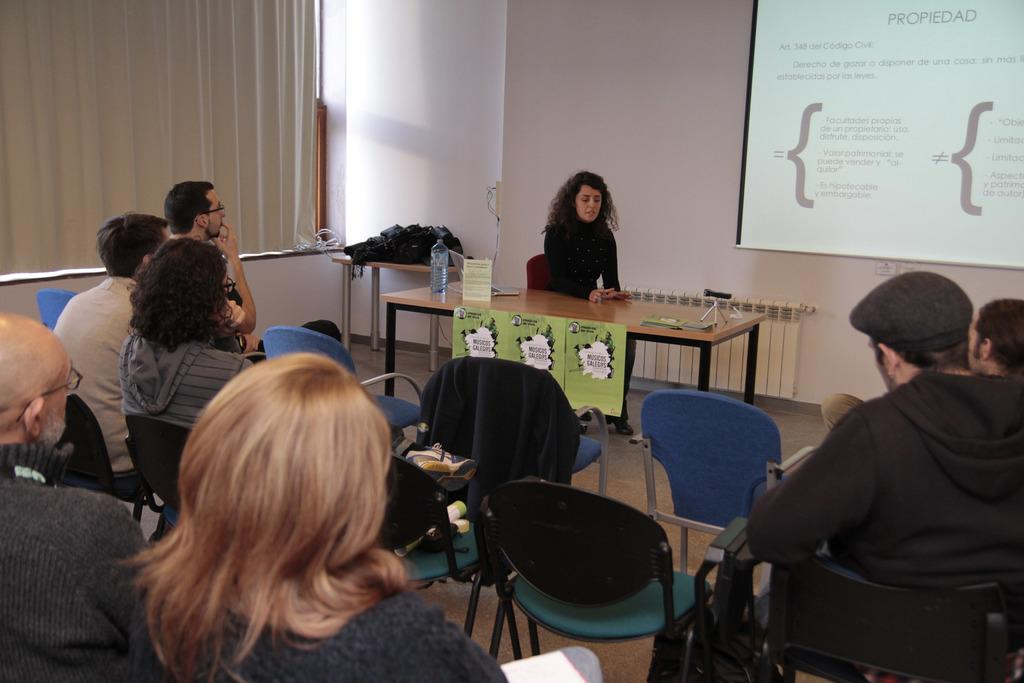What is the main subject of the image? The main subject of the image is a group of people. Can you describe one person in the image? There is a woman in the image. What is the woman doing? The woman is explaining something. What is located beside the woman? There is a screen beside the woman. What type of fruit is the woman holding in the image? There is no fruit present in the image; the woman is explaining something with a screen beside her. 